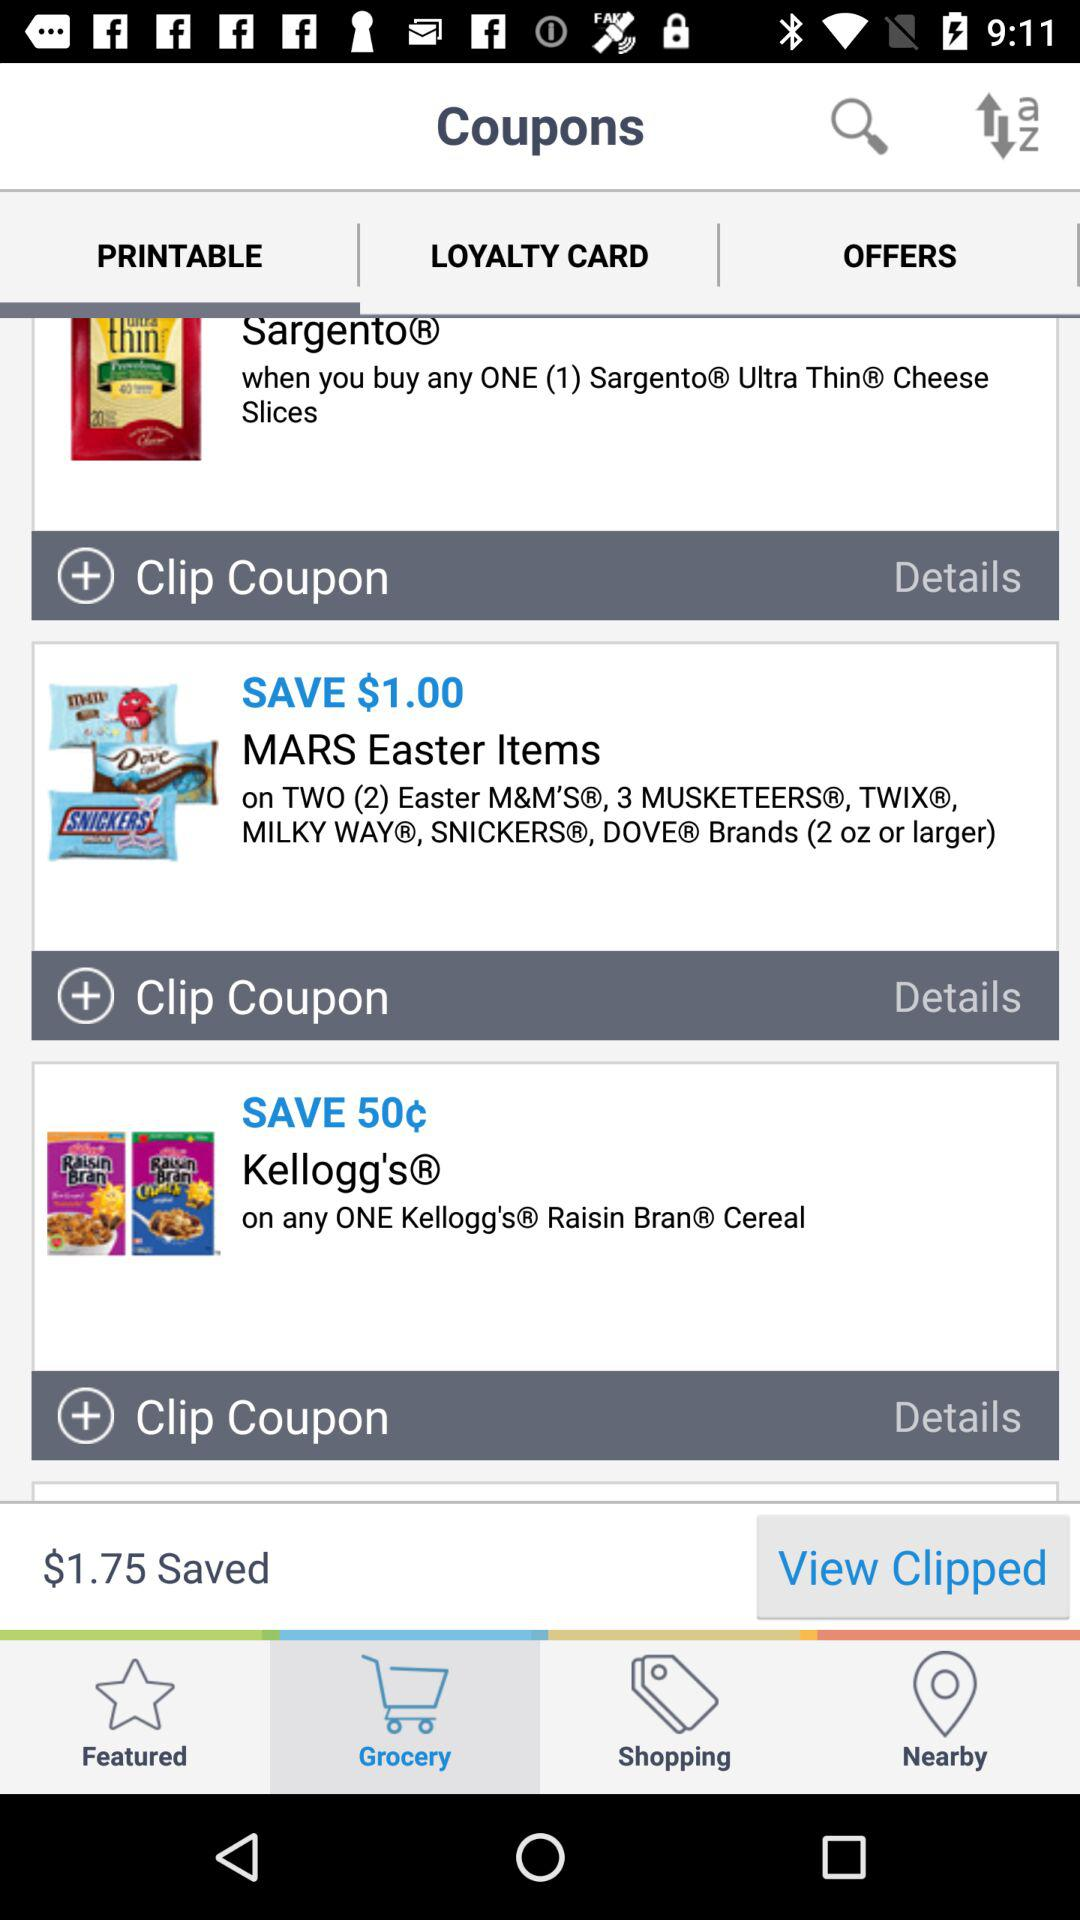How much money can be saved on "Kellogg's"? The money that can be saved on "Kellogg's" is 50¢. 